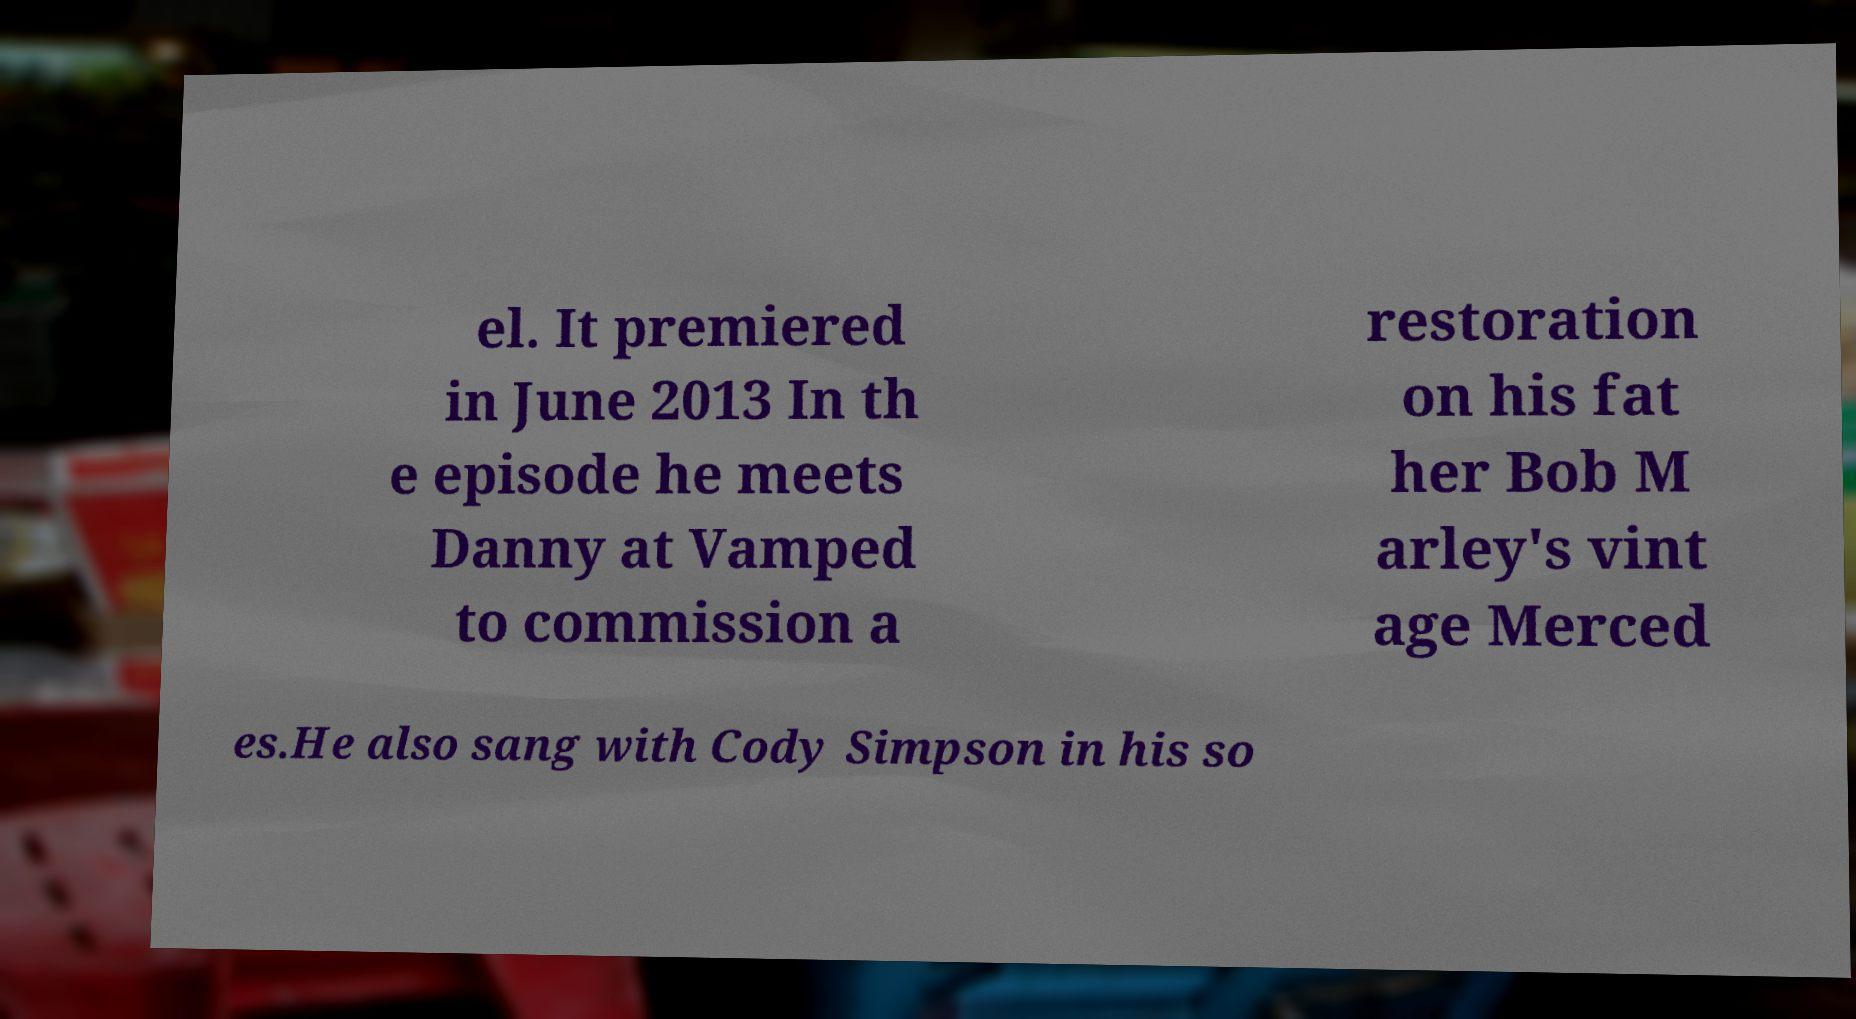What messages or text are displayed in this image? I need them in a readable, typed format. el. It premiered in June 2013 In th e episode he meets Danny at Vamped to commission a restoration on his fat her Bob M arley's vint age Merced es.He also sang with Cody Simpson in his so 